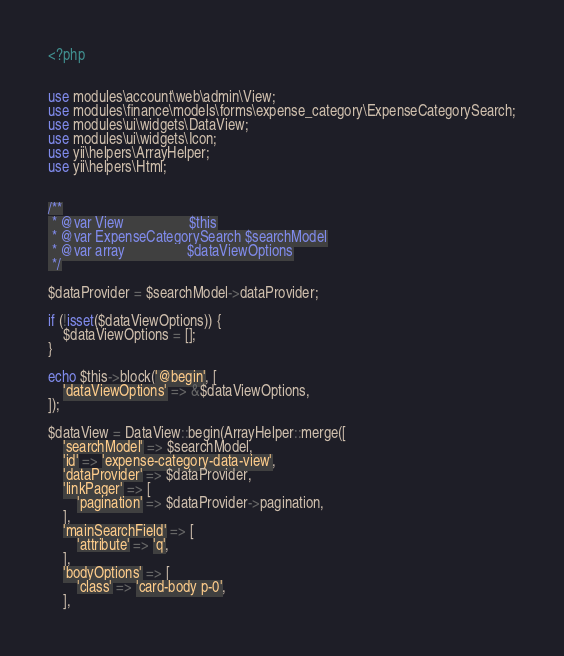<code> <loc_0><loc_0><loc_500><loc_500><_PHP_><?php


use modules\account\web\admin\View;
use modules\finance\models\forms\expense_category\ExpenseCategorySearch;
use modules\ui\widgets\DataView;
use modules\ui\widgets\Icon;
use yii\helpers\ArrayHelper;
use yii\helpers\Html;


/**
 * @var View                  $this
 * @var ExpenseCategorySearch $searchModel
 * @var array                 $dataViewOptions
 */

$dataProvider = $searchModel->dataProvider;

if (!isset($dataViewOptions)) {
    $dataViewOptions = [];
}

echo $this->block('@begin', [
    'dataViewOptions' => &$dataViewOptions,
]);

$dataView = DataView::begin(ArrayHelper::merge([
    'searchModel' => $searchModel,
    'id' => 'expense-category-data-view',
    'dataProvider' => $dataProvider,
    'linkPager' => [
        'pagination' => $dataProvider->pagination,
    ],
    'mainSearchField' => [
        'attribute' => 'q',
    ],
    'bodyOptions' => [
        'class' => 'card-body p-0',
    ],</code> 